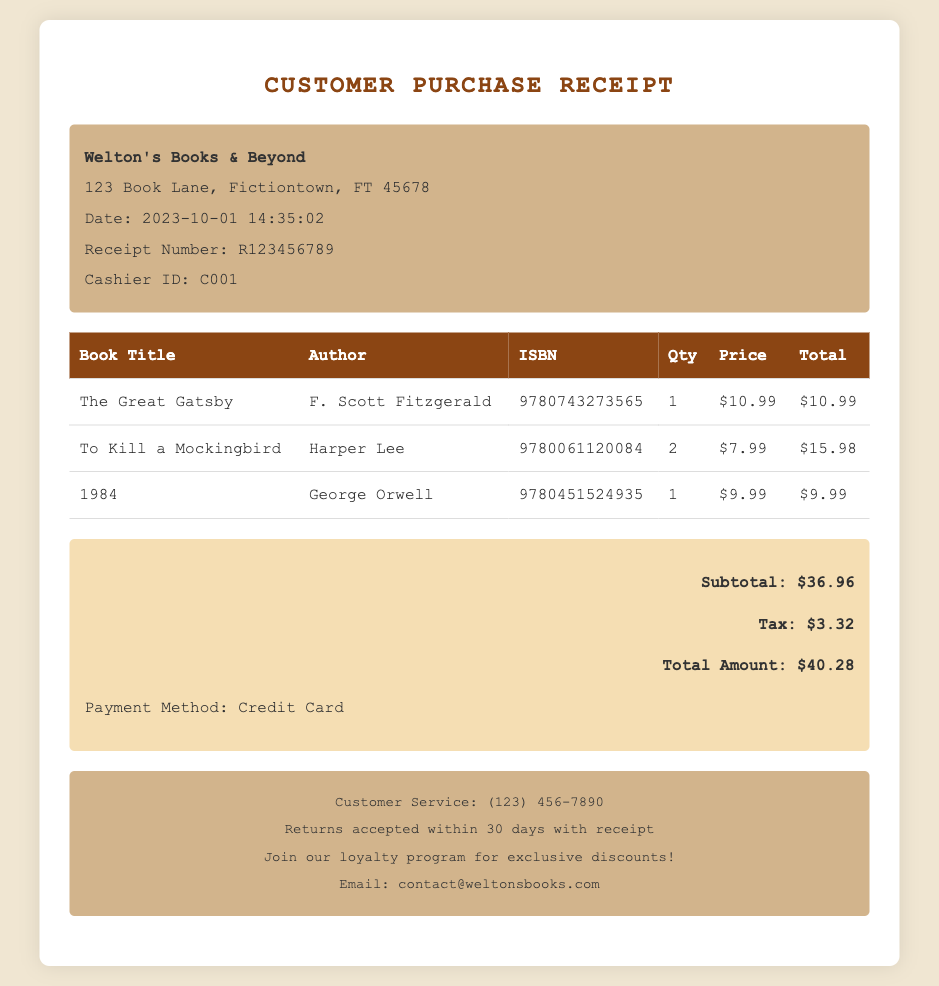what is the date of the purchase? The date of the purchase is mentioned prominently on the receipt as 2023-10-01.
Answer: 2023-10-01 what is the receipt number? The receipt number is indicated on the document as R123456789.
Answer: R123456789 how many copies of 'To Kill a Mockingbird' were purchased? The quantity of 'To Kill a Mockingbird' is listed in the receipt as 2.
Answer: 2 what is the total amount paid? The total amount paid is the final figure at the bottom of the receipt, which is $40.28.
Answer: $40.28 what is the payment method used? The document states that the payment method used for the purchase was a Credit Card.
Answer: Credit Card who is the author of '1984'? The author of '1984' is listed in the document as George Orwell.
Answer: George Orwell what is the tax amount included in the total? The tax amount can be found within the payment details of the receipt as $3.32.
Answer: $3.32 how many items were purchased in total? The total quantity of items purchased can be calculated by adding the quantities listed, which is 1 + 2 + 1 = 4.
Answer: 4 where is Welton's Books & Beyond located? The location of Welton's Books & Beyond is explicitly stated as 123 Book Lane, Fictiontown, FT 45678.
Answer: 123 Book Lane, Fictiontown, FT 45678 